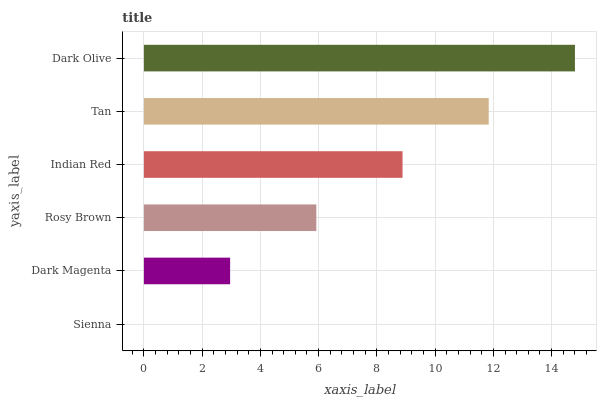Is Sienna the minimum?
Answer yes or no. Yes. Is Dark Olive the maximum?
Answer yes or no. Yes. Is Dark Magenta the minimum?
Answer yes or no. No. Is Dark Magenta the maximum?
Answer yes or no. No. Is Dark Magenta greater than Sienna?
Answer yes or no. Yes. Is Sienna less than Dark Magenta?
Answer yes or no. Yes. Is Sienna greater than Dark Magenta?
Answer yes or no. No. Is Dark Magenta less than Sienna?
Answer yes or no. No. Is Indian Red the high median?
Answer yes or no. Yes. Is Rosy Brown the low median?
Answer yes or no. Yes. Is Sienna the high median?
Answer yes or no. No. Is Tan the low median?
Answer yes or no. No. 